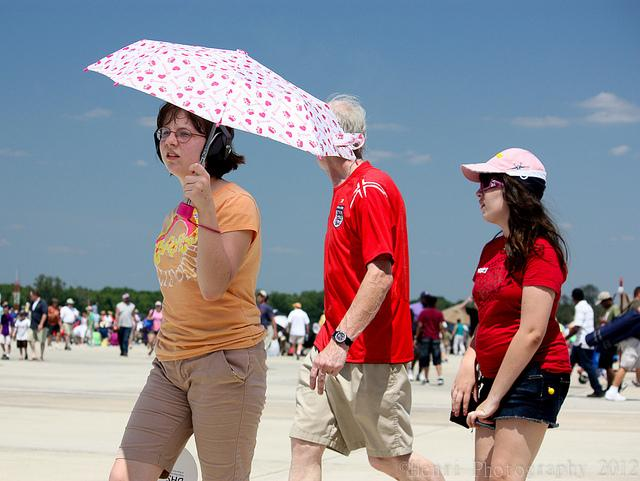The person holding the umbrella looks most like who?

Choices:
A) lily frazer
B) albert finney
C) amber tamblyn
D) adewale akinnuoyeagbaje amber tamblyn 